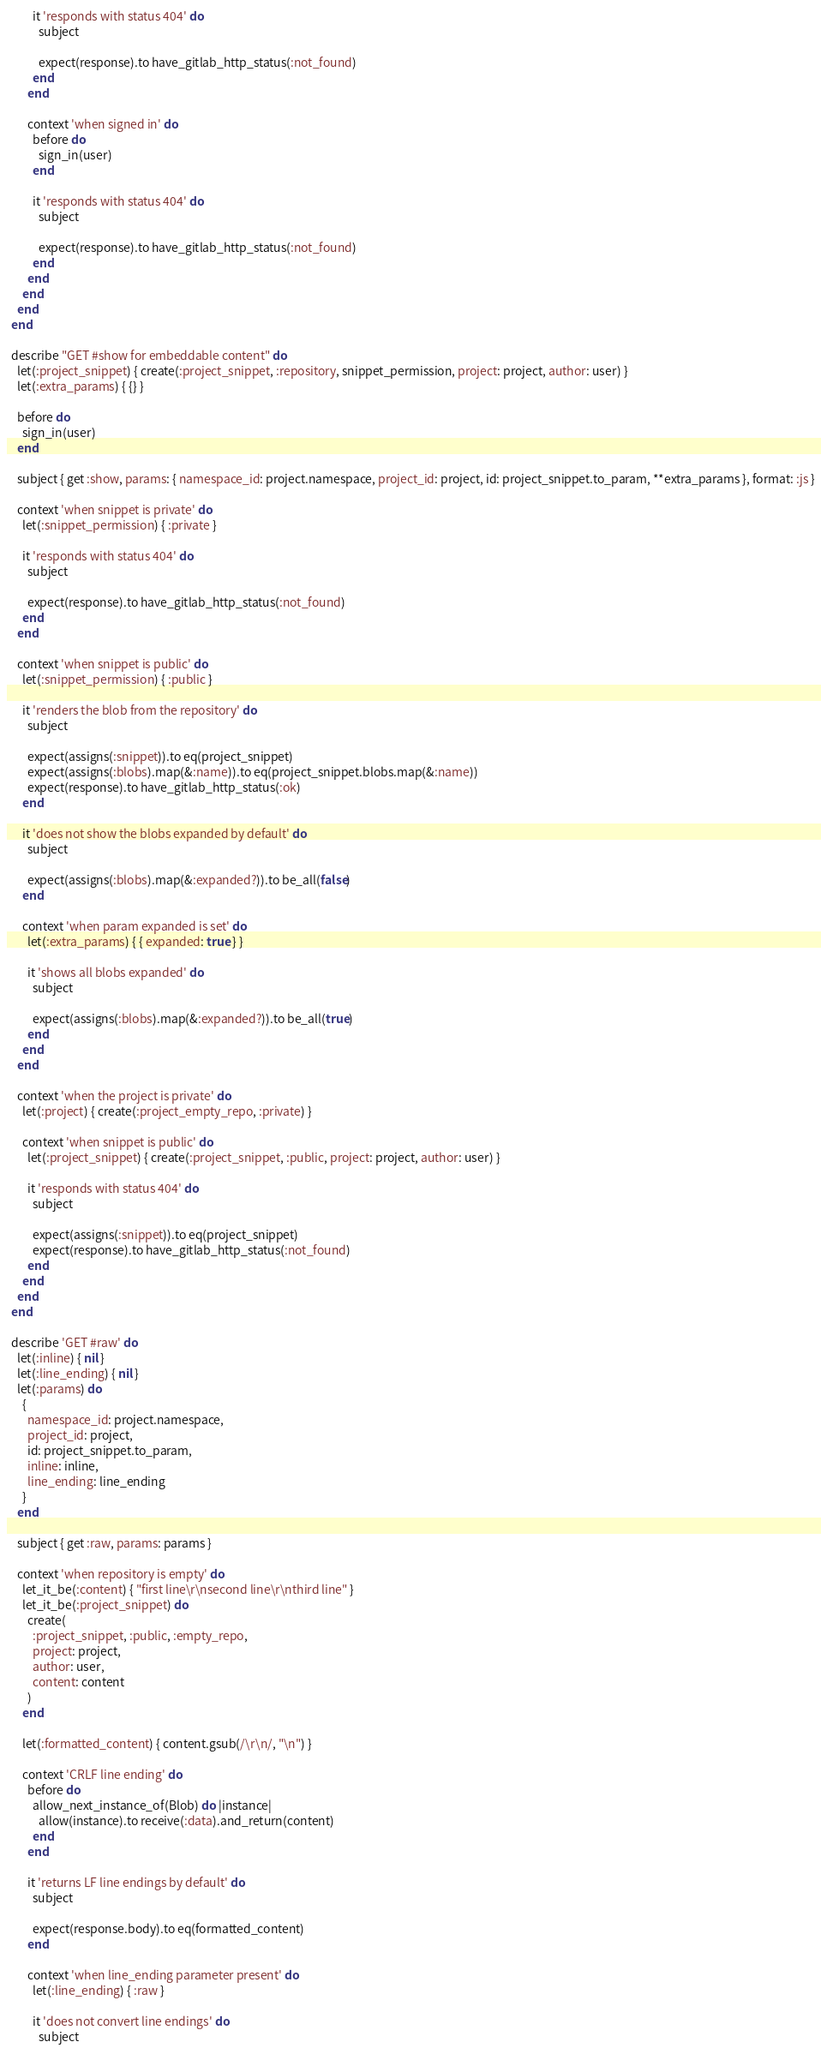Convert code to text. <code><loc_0><loc_0><loc_500><loc_500><_Ruby_>          it 'responds with status 404' do
            subject

            expect(response).to have_gitlab_http_status(:not_found)
          end
        end

        context 'when signed in' do
          before do
            sign_in(user)
          end

          it 'responds with status 404' do
            subject

            expect(response).to have_gitlab_http_status(:not_found)
          end
        end
      end
    end
  end

  describe "GET #show for embeddable content" do
    let(:project_snippet) { create(:project_snippet, :repository, snippet_permission, project: project, author: user) }
    let(:extra_params) { {} }

    before do
      sign_in(user)
    end

    subject { get :show, params: { namespace_id: project.namespace, project_id: project, id: project_snippet.to_param, **extra_params }, format: :js }

    context 'when snippet is private' do
      let(:snippet_permission) { :private }

      it 'responds with status 404' do
        subject

        expect(response).to have_gitlab_http_status(:not_found)
      end
    end

    context 'when snippet is public' do
      let(:snippet_permission) { :public }

      it 'renders the blob from the repository' do
        subject

        expect(assigns(:snippet)).to eq(project_snippet)
        expect(assigns(:blobs).map(&:name)).to eq(project_snippet.blobs.map(&:name))
        expect(response).to have_gitlab_http_status(:ok)
      end

      it 'does not show the blobs expanded by default' do
        subject

        expect(assigns(:blobs).map(&:expanded?)).to be_all(false)
      end

      context 'when param expanded is set' do
        let(:extra_params) { { expanded: true } }

        it 'shows all blobs expanded' do
          subject

          expect(assigns(:blobs).map(&:expanded?)).to be_all(true)
        end
      end
    end

    context 'when the project is private' do
      let(:project) { create(:project_empty_repo, :private) }

      context 'when snippet is public' do
        let(:project_snippet) { create(:project_snippet, :public, project: project, author: user) }

        it 'responds with status 404' do
          subject

          expect(assigns(:snippet)).to eq(project_snippet)
          expect(response).to have_gitlab_http_status(:not_found)
        end
      end
    end
  end

  describe 'GET #raw' do
    let(:inline) { nil }
    let(:line_ending) { nil }
    let(:params) do
      {
        namespace_id: project.namespace,
        project_id: project,
        id: project_snippet.to_param,
        inline: inline,
        line_ending: line_ending
      }
    end

    subject { get :raw, params: params }

    context 'when repository is empty' do
      let_it_be(:content) { "first line\r\nsecond line\r\nthird line" }
      let_it_be(:project_snippet) do
        create(
          :project_snippet, :public, :empty_repo,
          project: project,
          author: user,
          content: content
        )
      end

      let(:formatted_content) { content.gsub(/\r\n/, "\n") }

      context 'CRLF line ending' do
        before do
          allow_next_instance_of(Blob) do |instance|
            allow(instance).to receive(:data).and_return(content)
          end
        end

        it 'returns LF line endings by default' do
          subject

          expect(response.body).to eq(formatted_content)
        end

        context 'when line_ending parameter present' do
          let(:line_ending) { :raw }

          it 'does not convert line endings' do
            subject
</code> 